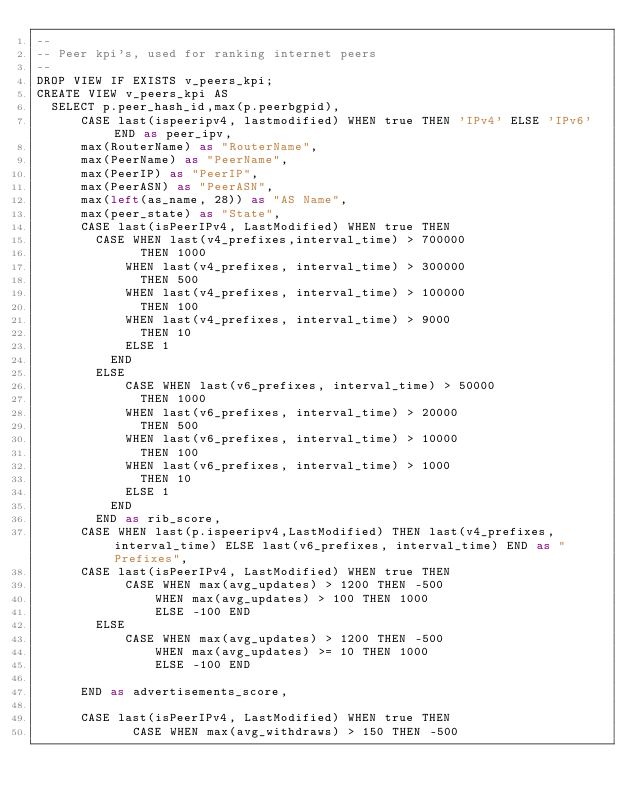<code> <loc_0><loc_0><loc_500><loc_500><_SQL_>--
-- Peer kpi's, used for ranking internet peers
--
DROP VIEW IF EXISTS v_peers_kpi;
CREATE VIEW v_peers_kpi AS
  SELECT p.peer_hash_id,max(p.peerbgpid),
      CASE last(ispeeripv4, lastmodified) WHEN true THEN 'IPv4' ELSE 'IPv6' END as peer_ipv,
      max(RouterName) as "RouterName",
      max(PeerName) as "PeerName",
      max(PeerIP) as "PeerIP",
      max(PeerASN) as "PeerASN",
      max(left(as_name, 28)) as "AS Name",
      max(peer_state) as "State",
      CASE last(isPeerIPv4, LastModified) WHEN true THEN
        CASE WHEN last(v4_prefixes,interval_time) > 700000
              THEN 1000
            WHEN last(v4_prefixes, interval_time) > 300000
              THEN 500
            WHEN last(v4_prefixes, interval_time) > 100000
              THEN 100
            WHEN last(v4_prefixes, interval_time) > 9000
              THEN 10
            ELSE 1
          END
        ELSE
            CASE WHEN last(v6_prefixes, interval_time) > 50000
              THEN 1000
            WHEN last(v6_prefixes, interval_time) > 20000
              THEN 500
            WHEN last(v6_prefixes, interval_time) > 10000
              THEN 100
            WHEN last(v6_prefixes, interval_time) > 1000
              THEN 10
            ELSE 1
          END
        END as rib_score,
      CASE WHEN last(p.ispeeripv4,LastModified) THEN last(v4_prefixes, interval_time) ELSE last(v6_prefixes, interval_time) END as "Prefixes",
      CASE last(isPeerIPv4, LastModified) WHEN true THEN
            CASE WHEN max(avg_updates) > 1200 THEN -500
                WHEN max(avg_updates) > 100 THEN 1000
                ELSE -100 END
        ELSE
            CASE WHEN max(avg_updates) > 1200 THEN -500
                WHEN max(avg_updates) >= 10 THEN 1000
                ELSE -100 END

      END as advertisements_score,

      CASE last(isPeerIPv4, LastModified) WHEN true THEN
             CASE WHEN max(avg_withdraws) > 150 THEN -500</code> 